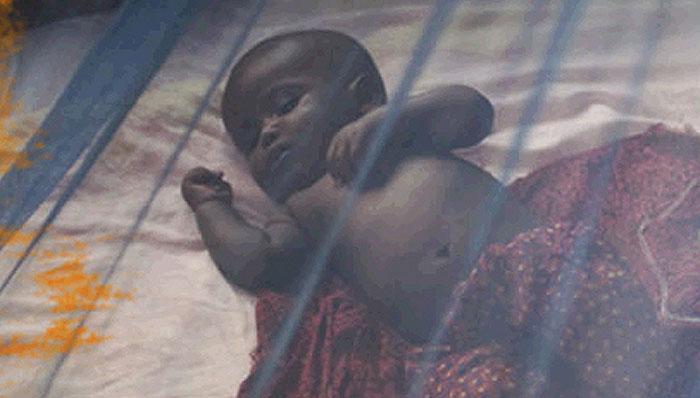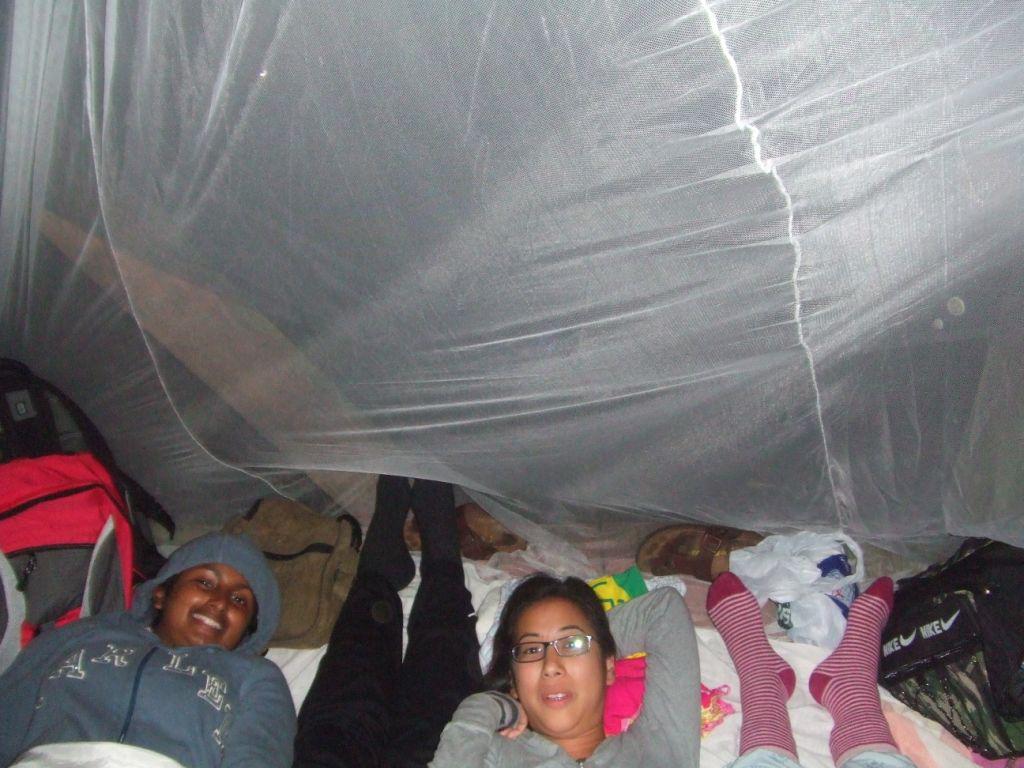The first image is the image on the left, the second image is the image on the right. Assess this claim about the two images: "An image includes a young baby sleeping under a protective net.". Correct or not? Answer yes or no. Yes. 